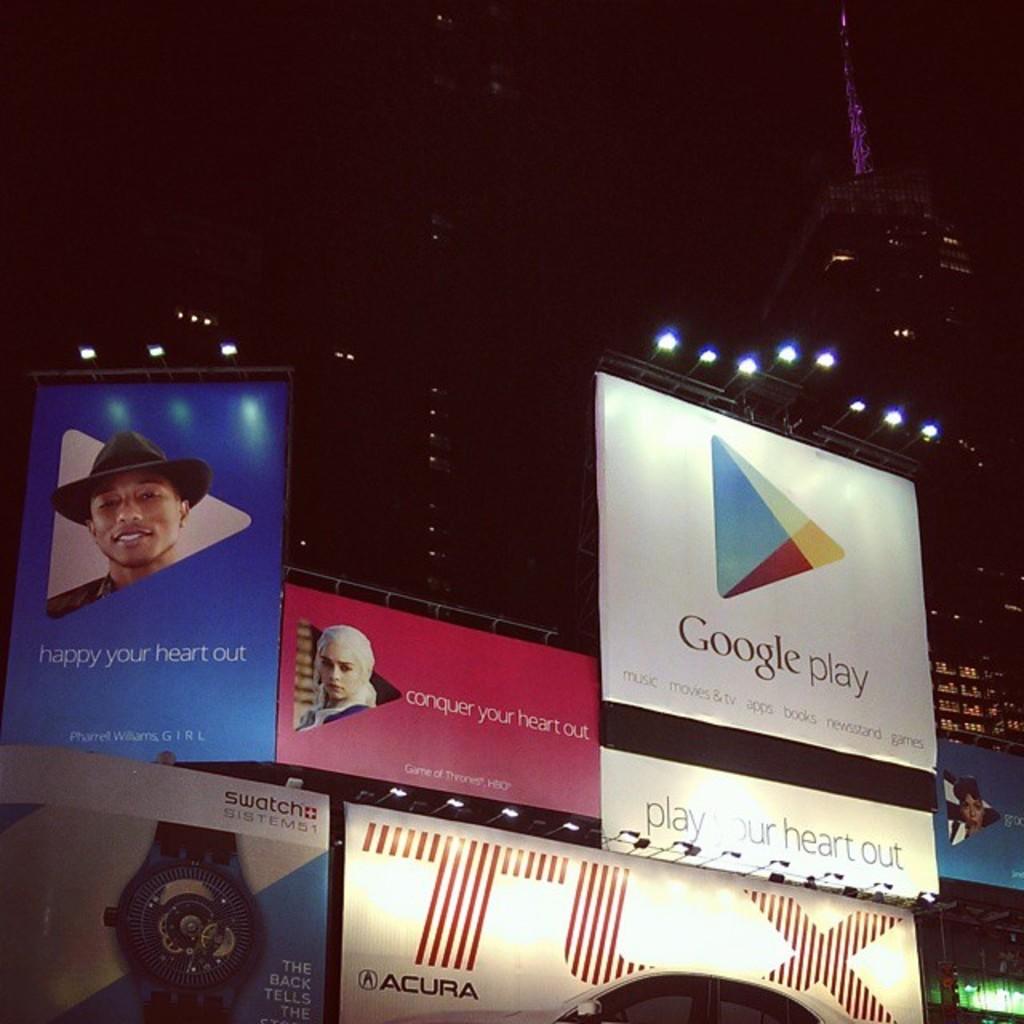What does the middle sign say to conquer?
Provide a short and direct response. Your heart out. What company is being advertised on the white sign?
Make the answer very short. Google. 